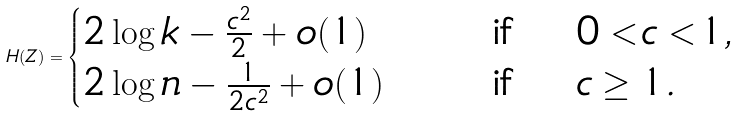Convert formula to latex. <formula><loc_0><loc_0><loc_500><loc_500>H ( Z ) = \begin{cases} 2 \log k - \frac { c ^ { 2 } } { 2 } + o ( 1 ) \quad & \text { if } \quad 0 < c < 1 , \\ 2 \log n - \frac { 1 } { 2 c ^ { 2 } } + o ( 1 ) \quad & \text { if } \quad c \geq 1 . \end{cases}</formula> 